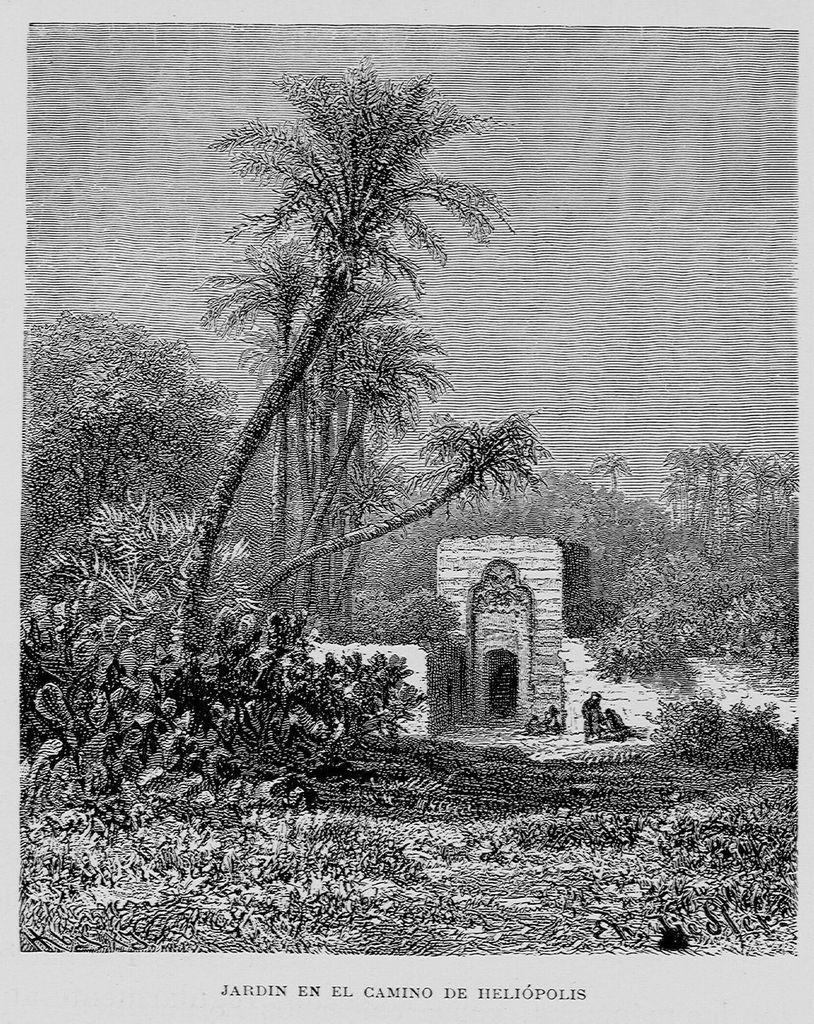What is the main subject of the image? The main subject of the image is a poster with images. What else can be seen on the poster besides the images? There is text on the poster. What type of environment is depicted in the image? The image shows many trees and plants on the ground. What is the color scheme of the image? The image is black and white. What type of territory is being claimed by the stomach in the image? There is no stomach or territory present in the image; it features a poster with images and text in a black and white environment. 